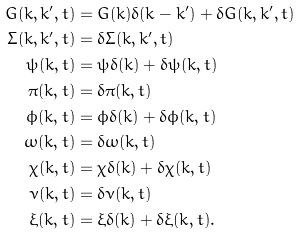<formula> <loc_0><loc_0><loc_500><loc_500>G ( k , k ^ { \prime } , t ) & = G ( k ) \delta ( k - k ^ { \prime } ) + \delta G ( k , k ^ { \prime } , t ) \\ \Sigma ( k , k ^ { \prime } , t ) & = \delta \Sigma ( k , k ^ { \prime } , t ) \\ \psi ( k , t ) & = \psi \delta ( k ) + \delta \psi ( k , t ) \\ \pi ( k , t ) & = \delta \pi ( k , t ) \\ \phi ( k , t ) & = \phi \delta ( k ) + \delta \phi ( k , t ) \\ \omega ( k , t ) & = \delta \omega ( k , t ) \\ \chi ( k , t ) & = \chi \delta ( k ) + \delta \chi ( k , t ) \\ \nu ( k , t ) & = \delta \nu ( k , t ) \\ \xi ( k , t ) & = \xi \delta ( k ) + \delta \xi ( k , t ) .</formula> 